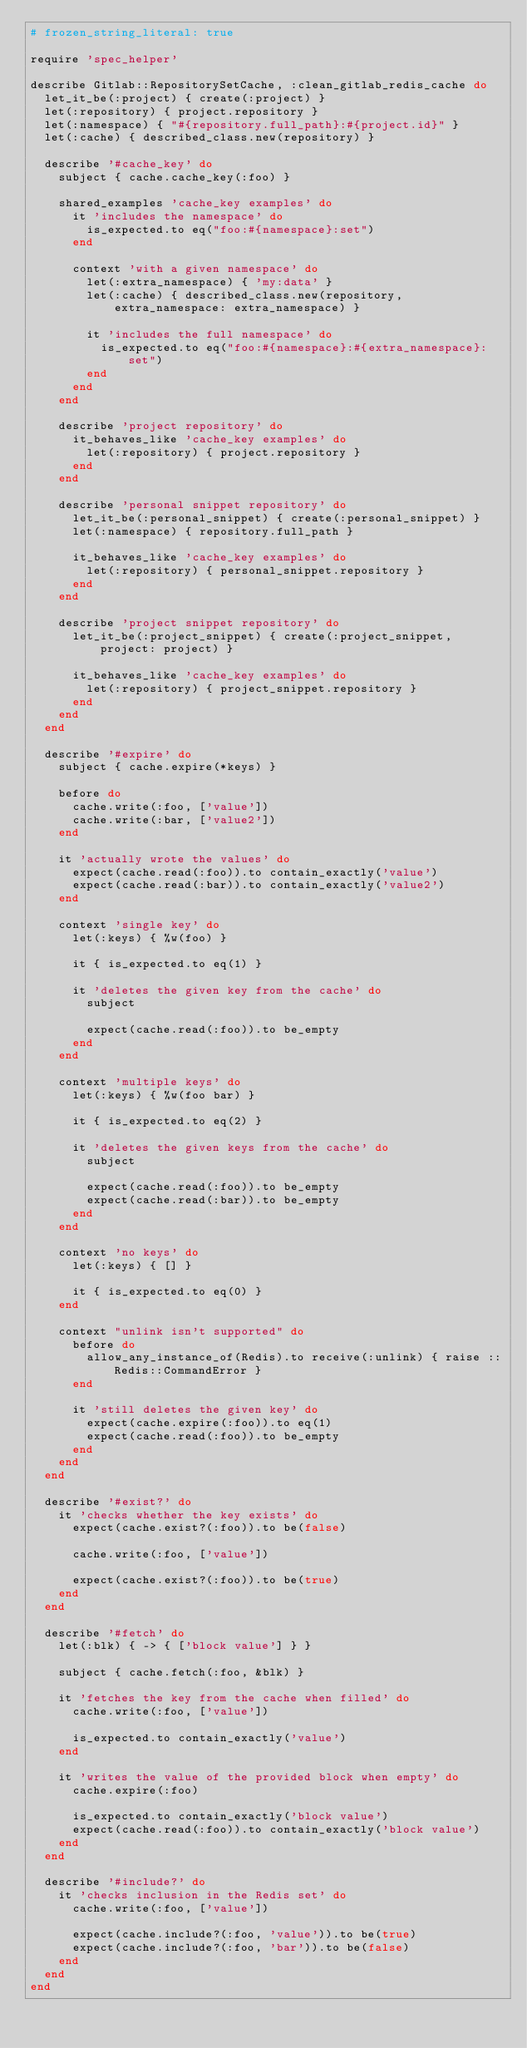<code> <loc_0><loc_0><loc_500><loc_500><_Ruby_># frozen_string_literal: true

require 'spec_helper'

describe Gitlab::RepositorySetCache, :clean_gitlab_redis_cache do
  let_it_be(:project) { create(:project) }
  let(:repository) { project.repository }
  let(:namespace) { "#{repository.full_path}:#{project.id}" }
  let(:cache) { described_class.new(repository) }

  describe '#cache_key' do
    subject { cache.cache_key(:foo) }

    shared_examples 'cache_key examples' do
      it 'includes the namespace' do
        is_expected.to eq("foo:#{namespace}:set")
      end

      context 'with a given namespace' do
        let(:extra_namespace) { 'my:data' }
        let(:cache) { described_class.new(repository, extra_namespace: extra_namespace) }

        it 'includes the full namespace' do
          is_expected.to eq("foo:#{namespace}:#{extra_namespace}:set")
        end
      end
    end

    describe 'project repository' do
      it_behaves_like 'cache_key examples' do
        let(:repository) { project.repository }
      end
    end

    describe 'personal snippet repository' do
      let_it_be(:personal_snippet) { create(:personal_snippet) }
      let(:namespace) { repository.full_path }

      it_behaves_like 'cache_key examples' do
        let(:repository) { personal_snippet.repository }
      end
    end

    describe 'project snippet repository' do
      let_it_be(:project_snippet) { create(:project_snippet, project: project) }

      it_behaves_like 'cache_key examples' do
        let(:repository) { project_snippet.repository }
      end
    end
  end

  describe '#expire' do
    subject { cache.expire(*keys) }

    before do
      cache.write(:foo, ['value'])
      cache.write(:bar, ['value2'])
    end

    it 'actually wrote the values' do
      expect(cache.read(:foo)).to contain_exactly('value')
      expect(cache.read(:bar)).to contain_exactly('value2')
    end

    context 'single key' do
      let(:keys) { %w(foo) }

      it { is_expected.to eq(1) }

      it 'deletes the given key from the cache' do
        subject

        expect(cache.read(:foo)).to be_empty
      end
    end

    context 'multiple keys' do
      let(:keys) { %w(foo bar) }

      it { is_expected.to eq(2) }

      it 'deletes the given keys from the cache' do
        subject

        expect(cache.read(:foo)).to be_empty
        expect(cache.read(:bar)).to be_empty
      end
    end

    context 'no keys' do
      let(:keys) { [] }

      it { is_expected.to eq(0) }
    end

    context "unlink isn't supported" do
      before do
        allow_any_instance_of(Redis).to receive(:unlink) { raise ::Redis::CommandError }
      end

      it 'still deletes the given key' do
        expect(cache.expire(:foo)).to eq(1)
        expect(cache.read(:foo)).to be_empty
      end
    end
  end

  describe '#exist?' do
    it 'checks whether the key exists' do
      expect(cache.exist?(:foo)).to be(false)

      cache.write(:foo, ['value'])

      expect(cache.exist?(:foo)).to be(true)
    end
  end

  describe '#fetch' do
    let(:blk) { -> { ['block value'] } }

    subject { cache.fetch(:foo, &blk) }

    it 'fetches the key from the cache when filled' do
      cache.write(:foo, ['value'])

      is_expected.to contain_exactly('value')
    end

    it 'writes the value of the provided block when empty' do
      cache.expire(:foo)

      is_expected.to contain_exactly('block value')
      expect(cache.read(:foo)).to contain_exactly('block value')
    end
  end

  describe '#include?' do
    it 'checks inclusion in the Redis set' do
      cache.write(:foo, ['value'])

      expect(cache.include?(:foo, 'value')).to be(true)
      expect(cache.include?(:foo, 'bar')).to be(false)
    end
  end
end
</code> 